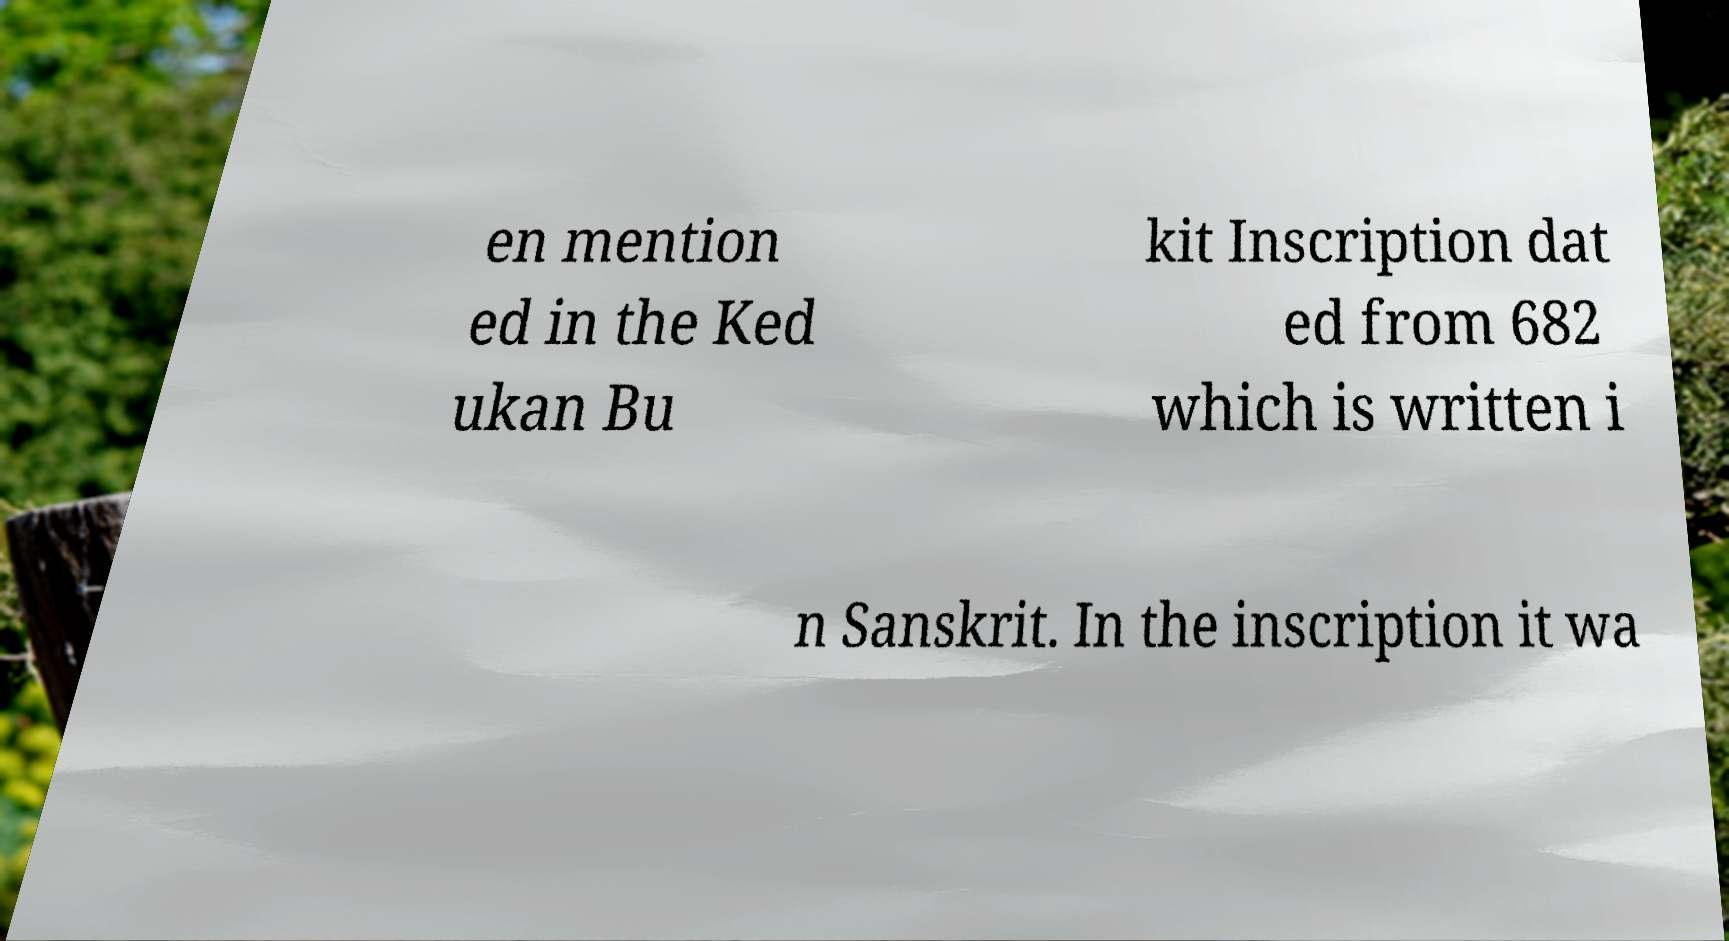There's text embedded in this image that I need extracted. Can you transcribe it verbatim? en mention ed in the Ked ukan Bu kit Inscription dat ed from 682 which is written i n Sanskrit. In the inscription it wa 